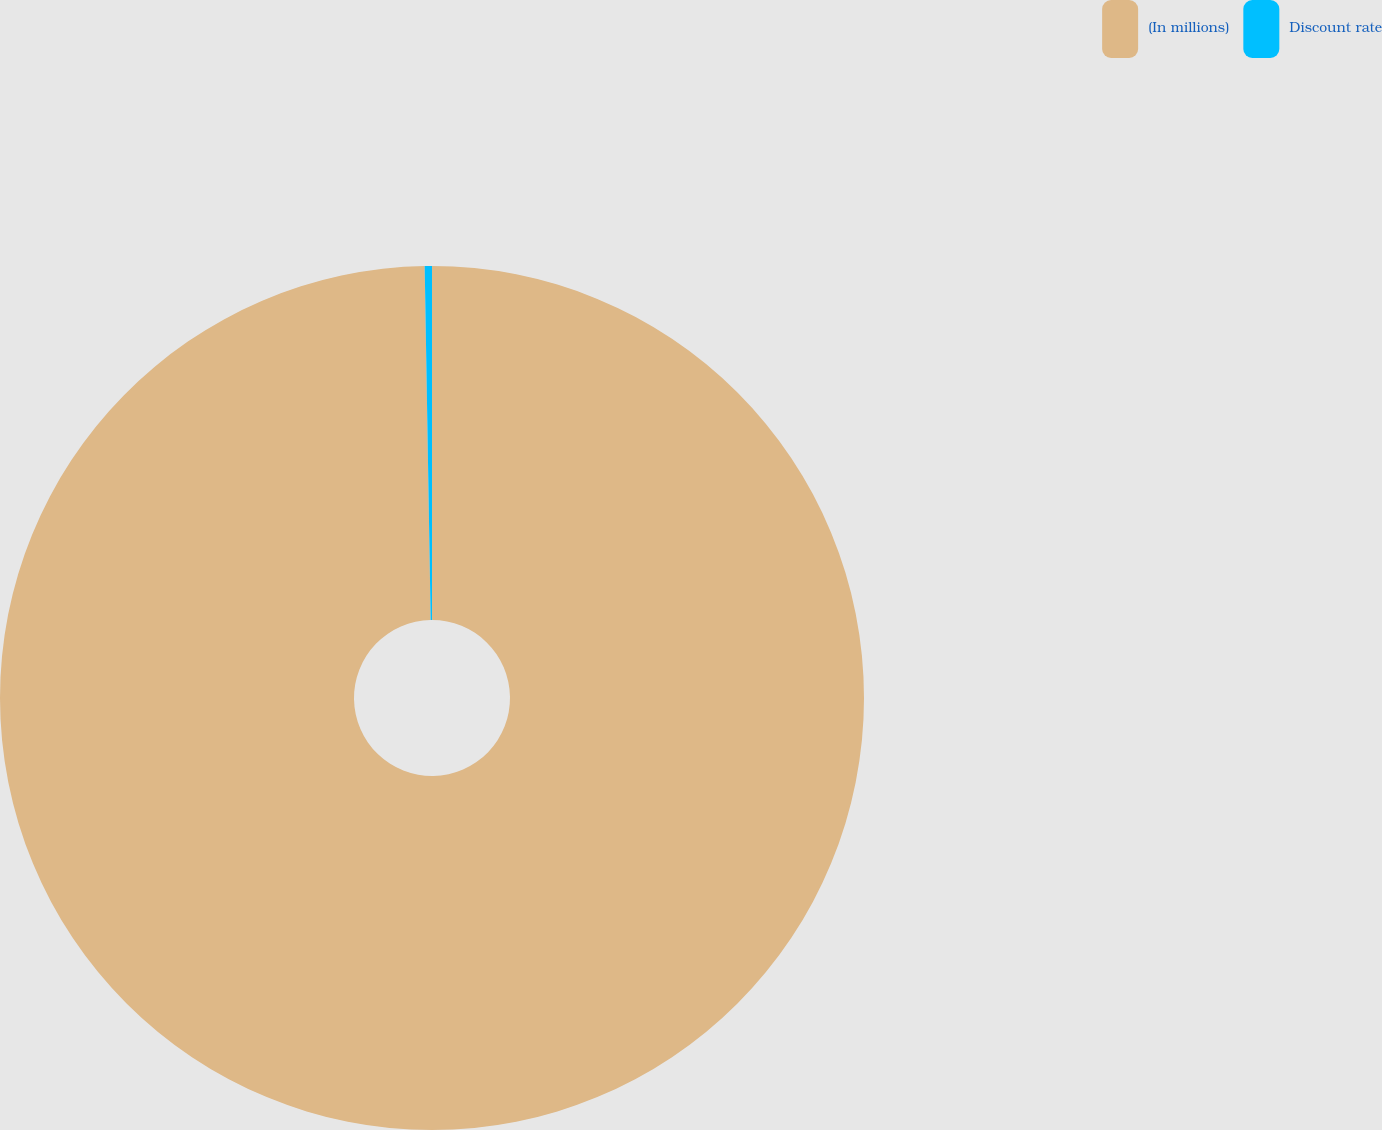Convert chart to OTSL. <chart><loc_0><loc_0><loc_500><loc_500><pie_chart><fcel>(In millions)<fcel>Discount rate<nl><fcel>99.73%<fcel>0.27%<nl></chart> 